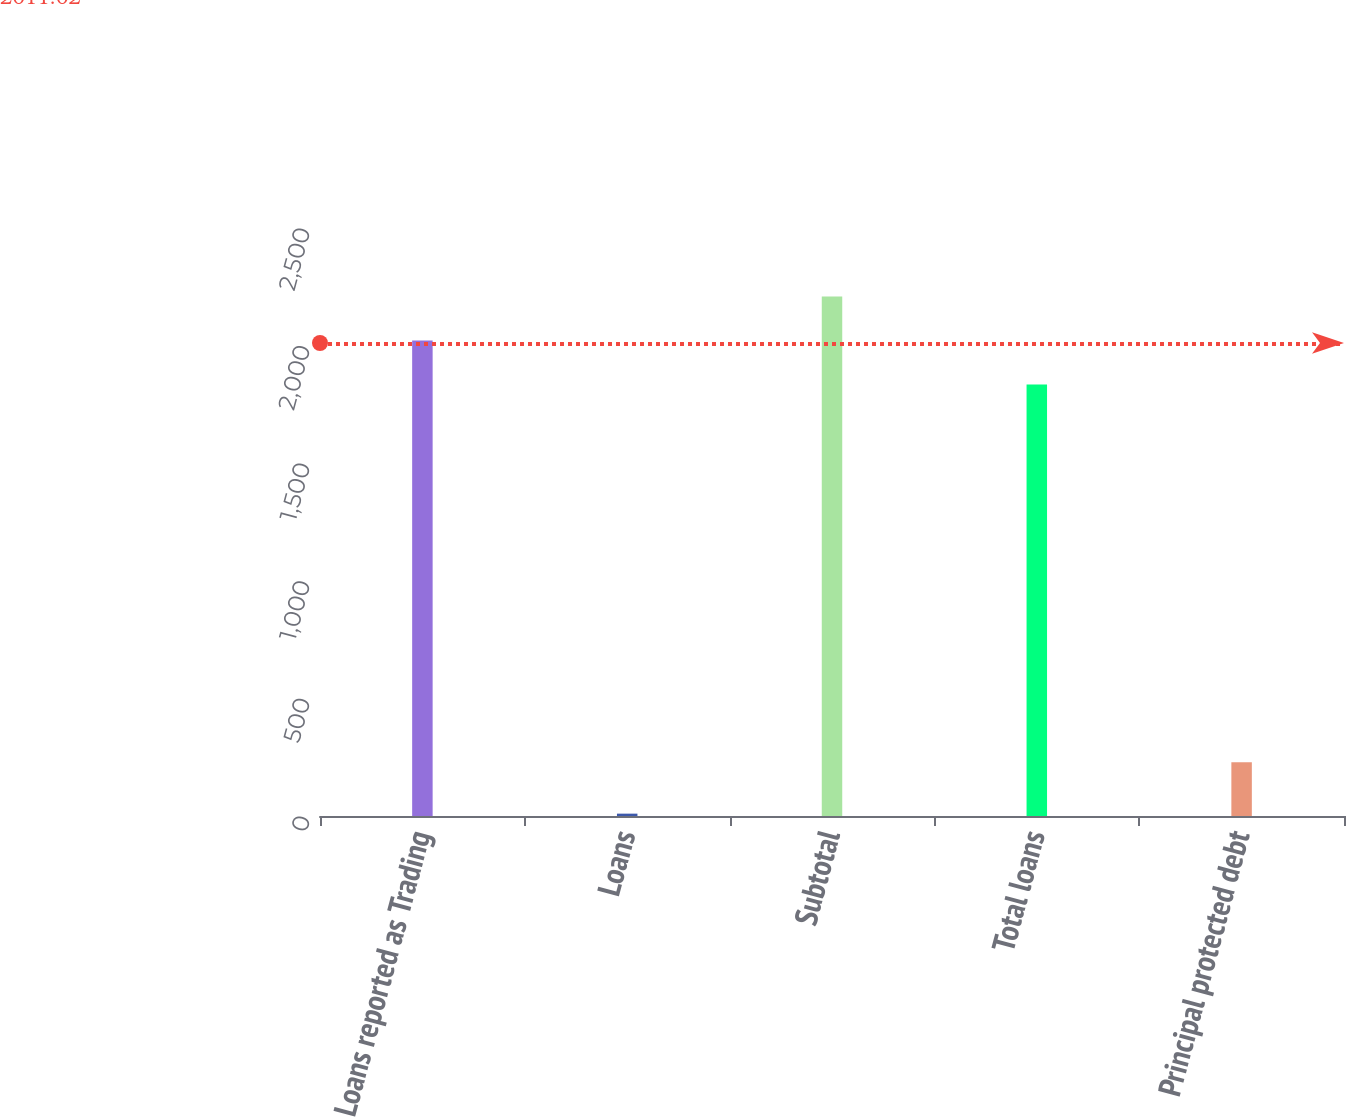Convert chart to OTSL. <chart><loc_0><loc_0><loc_500><loc_500><bar_chart><fcel>Loans reported as Trading<fcel>Loans<fcel>Subtotal<fcel>Total loans<fcel>Principal protected debt<nl><fcel>2021.8<fcel>10<fcel>2208.6<fcel>1835<fcel>229<nl></chart> 